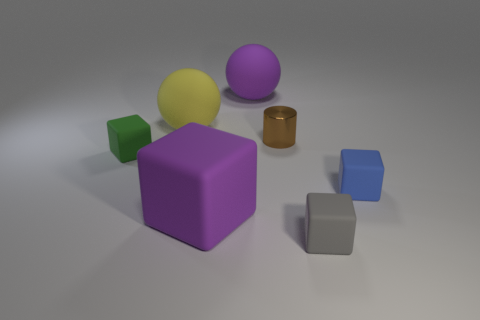Subtract all purple blocks. How many blocks are left? 3 Subtract all purple cubes. How many cubes are left? 3 Subtract 2 blocks. How many blocks are left? 2 Subtract all brown cubes. Subtract all red balls. How many cubes are left? 4 Add 3 cylinders. How many objects exist? 10 Subtract all balls. How many objects are left? 5 Subtract 0 blue balls. How many objects are left? 7 Subtract all cyan things. Subtract all rubber blocks. How many objects are left? 3 Add 3 large rubber objects. How many large rubber objects are left? 6 Add 2 cyan rubber balls. How many cyan rubber balls exist? 2 